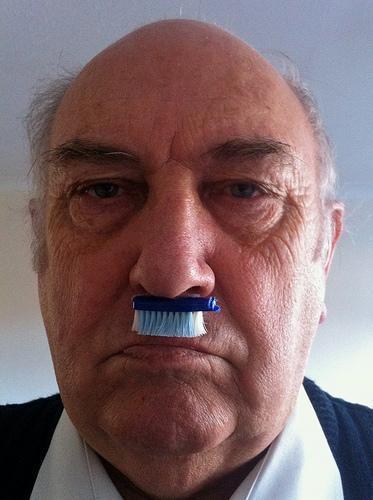How many people are in the scene?
Give a very brief answer. 1. 